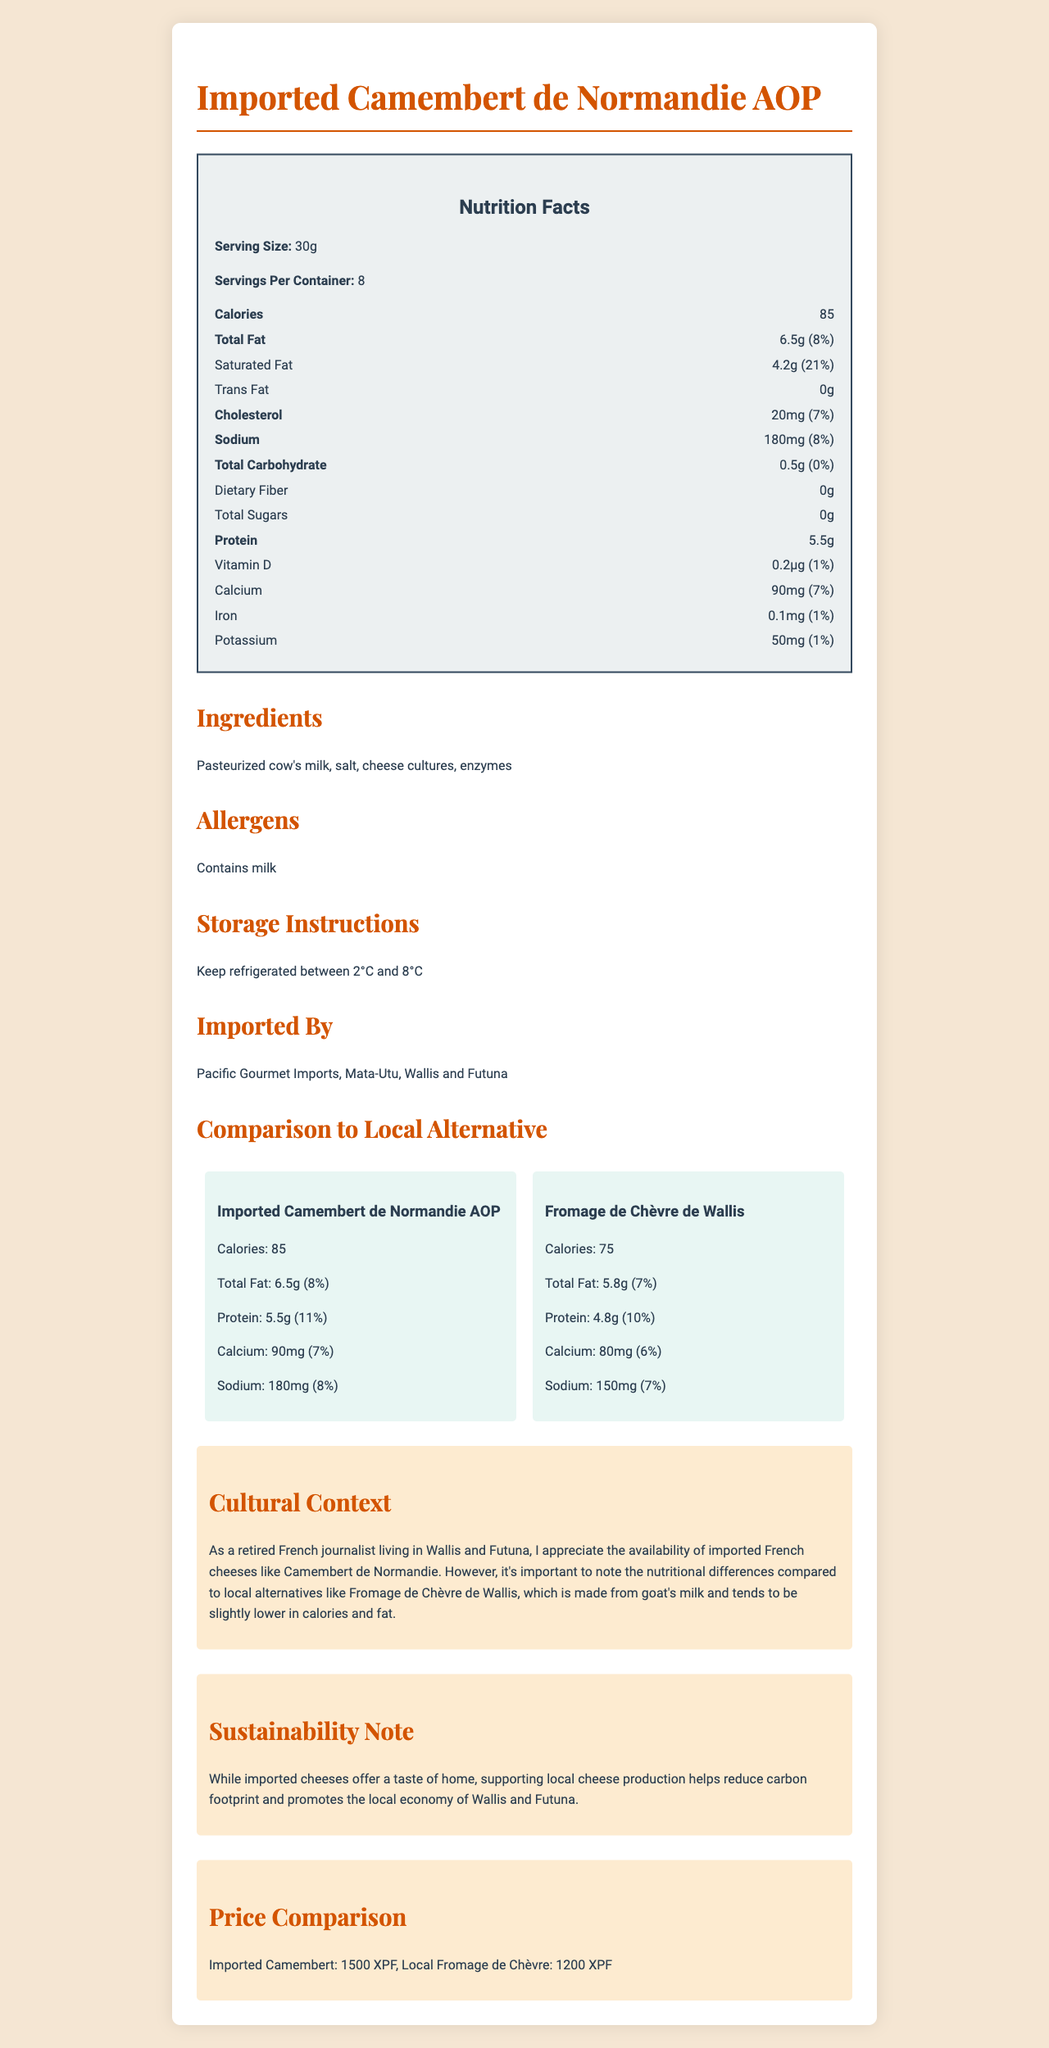what is the serving size of Imported Camembert de Normandie AOP? The document specifies the serving size for the Imported Camembert de Normandie AOP as 30g in the nutrition facts section.
Answer: 30g how many calories does one serving of Fromage de Chèvre de Wallis have? The nutrition comparison section of the document shows that one serving of Fromage de Chèvre de Wallis has 75 calories.
Answer: 75 which cheese has a higher total fat content per serving? A. Imported Camembert de Normandie AOP B. Fromage de Chèvre de Wallis The Imported Camembert de Normandie AOP has 6.5g of total fat per serving, whereas Fromage de Chèvre de Wallis has 5.8g.
Answer: A is the Imported Camembert de Normandie AOP higher in calcium than the Fromage de Chèvre de Wallis? The Imported Camembert de Normandie AOP has 90mg of calcium per serving, whereas Fromage de Chèvre de Wallis has 80mg.
Answer: Yes how does the sodium content of Imported Camembert de Normandie AOP compare to Fromage de Chèvre de Wallis? The document shows that Imported Camembert de Normandie AOP has 180mg of sodium, and Fromage de Chèvre de Wallis has 150mg.
Answer: Imported Camembert: 180mg, Fromage de Chèvre: 150mg which cheese is more cost-effective? A. Imported Camembert B. Local Fromage de Chèvre The price comparison section shows that the Local Fromage de Chèvre is 1200 XPF, while the Imported Camembert is 1500 XPF.
Answer: B is the imported cheese higher in protein content than the local cheese? The Imported Camembert de Normandie AOP has 5.5g of protein per serving, whereas Fromage de Chèvre de Wallis has 4.8g.
Answer: Yes what allergens are present in the Imported Camembert de Normandie AOP? The allergens section of the document lists milk as a component in the Imported Camembert de Normandie AOP.
Answer: Contains milk describe the main idea of this document This document provides detailed nutrition information for Imported Camembert de Normandie AOP and compares it with the local alternative, Fromage de Chèvre de Wallis. It includes calorie counts, fat, protein, calcium, and price comparisons, along with cultural and sustainability notes.
Answer: Nutrition and Comparison of Imported Camembert vs. Local Fromage de Chèvre what is the sustainability note provided in the document? The sustainability note explains the environmental and economic benefits of supporting local cheese production in Wallis and Futuna.
Answer: Supporting local cheese production helps reduce carbon footprint and promotes the local economy of Wallis and Futuna. how much vitamin D is in the Imported Camembert de Normandie AOP? The nutrition facts section states that the Imported Camembert de Normandie AOP contains 0.2µg of vitamin D per serving.
Answer: 0.2µg is the cholesterol content of Imported Camembert de Normandie AOP 30mg per serving? The document shows that the cholesterol content is 20mg per serving.
Answer: No who imported the cheese? The document specifies that the cheese is imported by Pacific Gourmet Imports, based in Mata-Utu, Wallis and Futuna.
Answer: Pacific Gourmet Imports, Mata-Utu, Wallis and Futuna which cheese has the higher protein daily value percentage (DV%)? A. Imported Camembert B. Fromage de Chèvre de Wallis The protein daily value percentage for Imported Camembert de Normandie AOP is 11%, while for Fromage de Chèvre de Wallis it is 10%.
Answer: A are ingredients of Imported Camembert de Normandie AOP specified in the document? The document lists the ingredients as pasteurized cow's milk, salt, cheese cultures, and enzymes.
Answer: Yes what is the percent daily value of calcium in Fromage de Chèvre de Wallis? The document states that Fromage de Chèvre de Wallis provides 6% of the daily value of calcium per serving.
Answer: 6% when should the imported cheese be stored? The storage instructions section indicates that the cheese should be kept refrigerated between 2°C and 8°C.
Answer: Between 2°C and 8°C what is the percent daily value of dietary fiber in both cheeses? The nutrition facts section indicates that both cheeses have 0% daily value of dietary fiber.
Answer: 0% what is the source of the cheese cultures in the Fromage de Chèvre de Wallis? The document doesn't provide specific information regarding the source of the cheese cultures in Fromage de Chèvre de Wallis.
Answer: Not enough information 